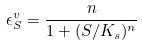Convert formula to latex. <formula><loc_0><loc_0><loc_500><loc_500>\epsilon _ { S } ^ { v } = \frac { n } { 1 + ( S / K _ { s } ) ^ { n } }</formula> 